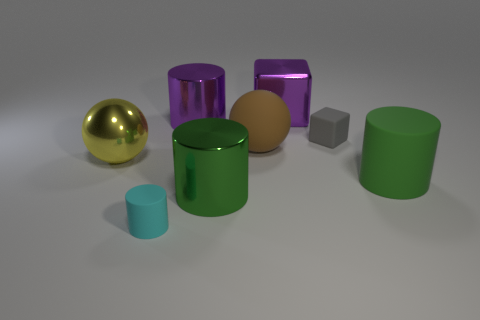Add 2 large green rubber cylinders. How many objects exist? 10 Subtract all blocks. How many objects are left? 6 Subtract all tiny rubber blocks. Subtract all small rubber cylinders. How many objects are left? 6 Add 4 brown things. How many brown things are left? 5 Add 5 purple shiny blocks. How many purple shiny blocks exist? 6 Subtract 0 brown cylinders. How many objects are left? 8 